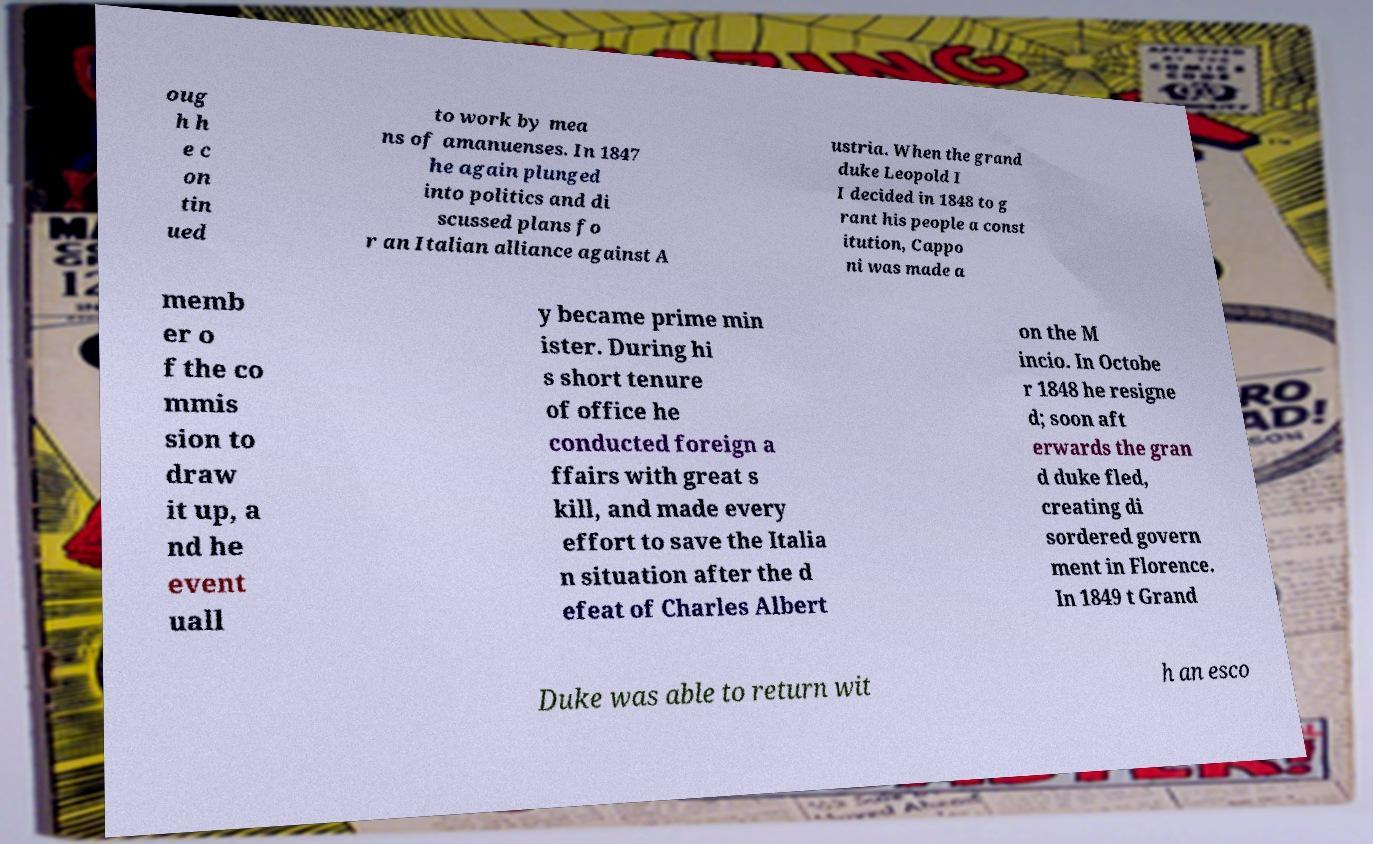There's text embedded in this image that I need extracted. Can you transcribe it verbatim? oug h h e c on tin ued to work by mea ns of amanuenses. In 1847 he again plunged into politics and di scussed plans fo r an Italian alliance against A ustria. When the grand duke Leopold I I decided in 1848 to g rant his people a const itution, Cappo ni was made a memb er o f the co mmis sion to draw it up, a nd he event uall y became prime min ister. During hi s short tenure of office he conducted foreign a ffairs with great s kill, and made every effort to save the Italia n situation after the d efeat of Charles Albert on the M incio. In Octobe r 1848 he resigne d; soon aft erwards the gran d duke fled, creating di sordered govern ment in Florence. In 1849 t Grand Duke was able to return wit h an esco 